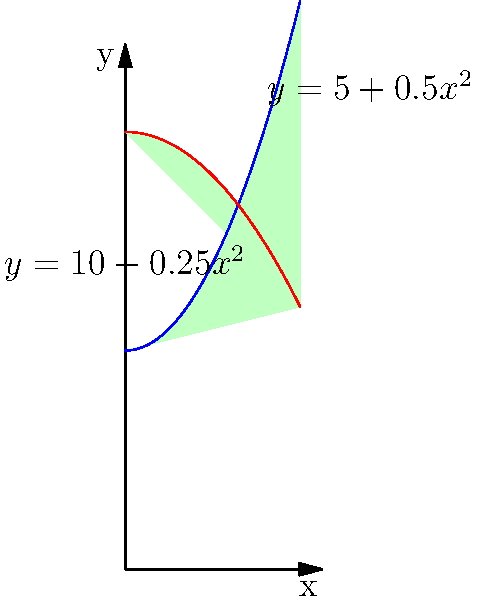A traditional Indian vase has a shape that can be modeled by rotating the region bounded by the curves $y = 5 + 0.5x^2$ and $y = 10 - 0.25x^2$ around the y-axis, where x and y are measured in inches. Calculate the volume of this vase using the method of cylindrical shells. To calculate the volume using cylindrical shells:

1) The volume is given by the formula: $V = 2\pi \int_a^b x[f(x) - g(x)]dx$
   where $f(x)$ is the outer function and $g(x)$ is the inner function.

2) In this case:
   $f(x) = 10 - 0.25x^2$
   $g(x) = 5 + 0.5x^2$

3) The limits of integration are from $x=0$ to the point where the curves intersect.
   To find this, set the equations equal:
   $10 - 0.25x^2 = 5 + 0.5x^2$
   $5 = 0.75x^2$
   $x^2 = \frac{20}{3}$
   $x = 2\sqrt{\frac{5}{3}} \approx 2.58$ inches

4) Now we can set up the integral:
   $V = 2\pi \int_0^{2\sqrt{\frac{5}{3}}} x[(10 - 0.25x^2) - (5 + 0.5x^2)]dx$

5) Simplify the integrand:
   $V = 2\pi \int_0^{2\sqrt{\frac{5}{3}}} x[5 - 0.75x^2]dx$

6) Integrate:
   $V = 2\pi [\frac{5x^2}{2} - \frac{0.75x^4}{4}]_0^{2\sqrt{\frac{5}{3}}}$

7) Evaluate the integral:
   $V = 2\pi [\frac{5(4\frac{5}{3})}{2} - \frac{0.75(16\frac{25}{9})}{4} - 0]$
   $V = 2\pi [\frac{100}{6} - \frac{100}{24}]$
   $V = 2\pi [\frac{100}{8}]$
   $V = 25\pi$ cubic inches
Answer: $25\pi$ cubic inches 